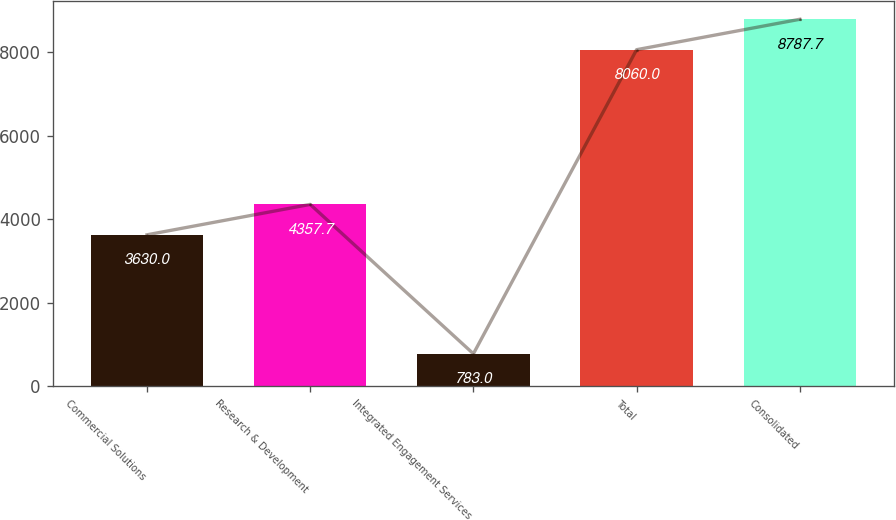Convert chart to OTSL. <chart><loc_0><loc_0><loc_500><loc_500><bar_chart><fcel>Commercial Solutions<fcel>Research & Development<fcel>Integrated Engagement Services<fcel>Total<fcel>Consolidated<nl><fcel>3630<fcel>4357.7<fcel>783<fcel>8060<fcel>8787.7<nl></chart> 